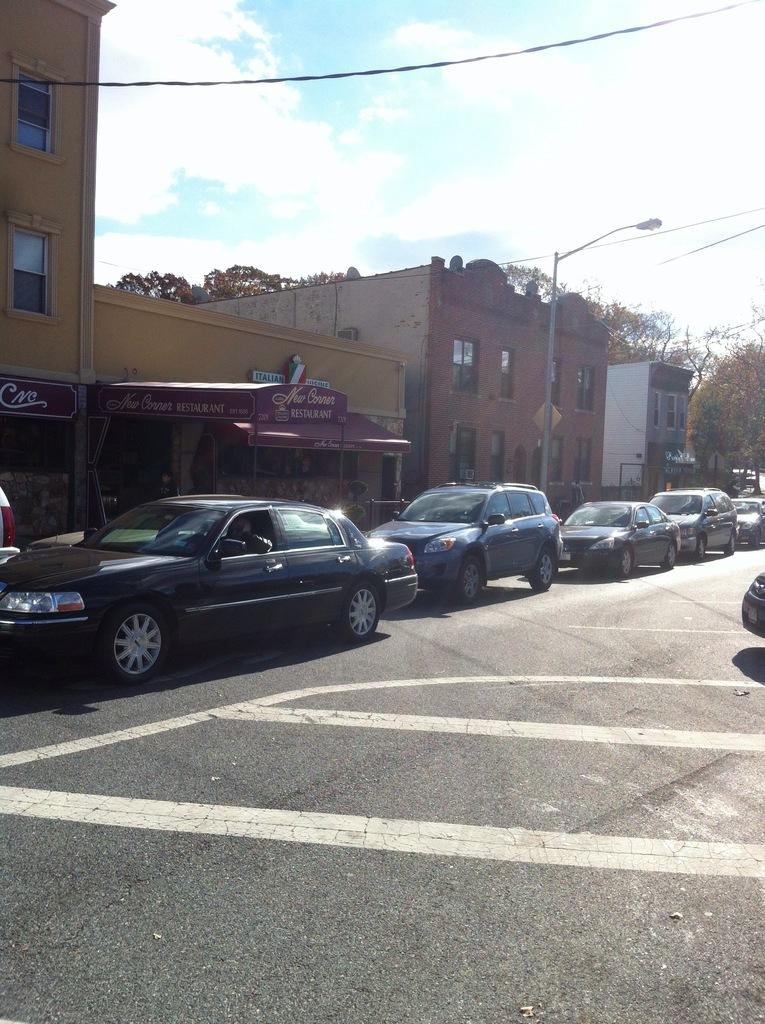What can be seen on the road in the image? There is a group of vehicles on the road in the image. What type of structures are visible in the image? There are buildings with windows in the image. What is the purpose of the street pole in the image? The street pole is likely used for holding traffic signals or street signs. What type of vegetation is present in the image? Trees are present in the image. What type of signs can be seen in the image? Sign boards are in the image. What type of infrastructure is visible in the image? Wires are visible in the image. What is the weather like in the image? The sky is cloudy in the image. What type of iron is used to create the buildings in the image? There is no information about the materials used to create the buildings in the image. What flavor of mint can be seen growing near the trees in the image? There is no mint plant visible in the image. 